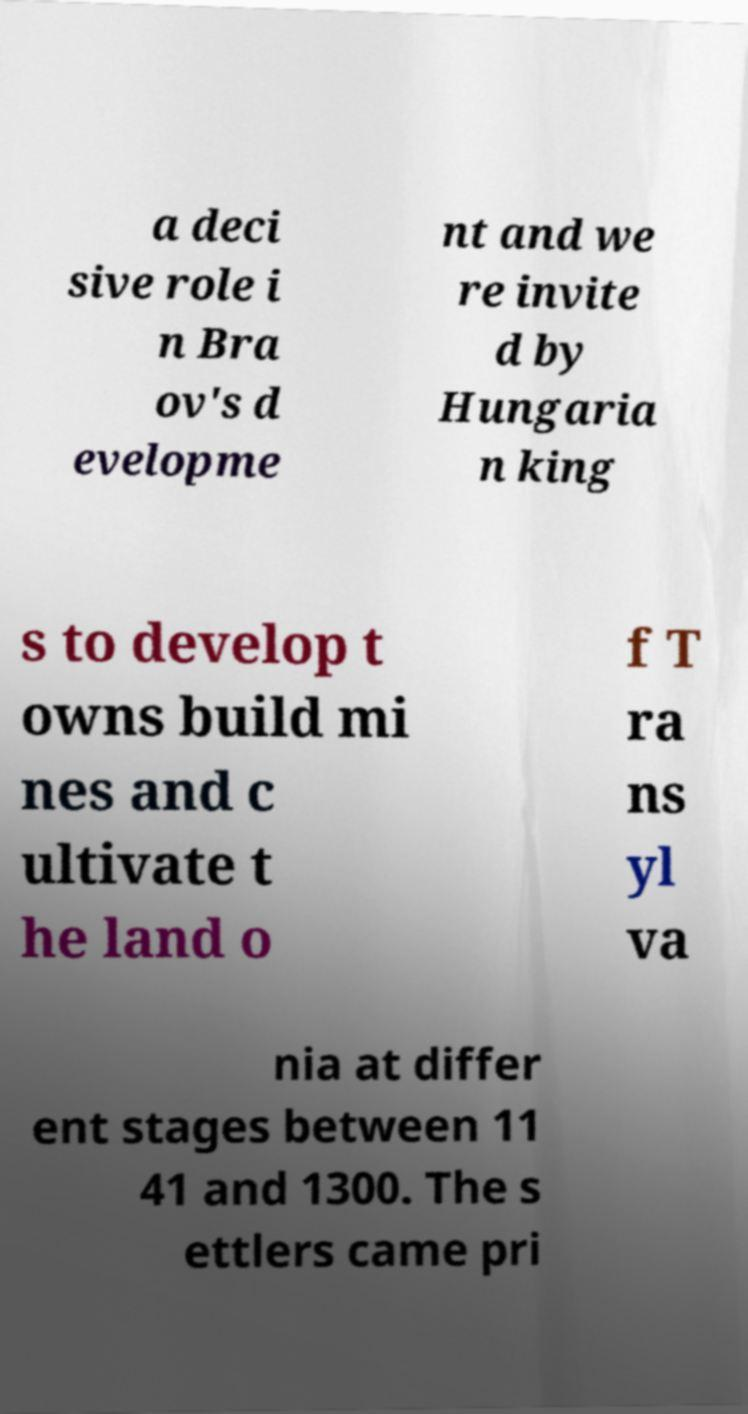Could you extract and type out the text from this image? a deci sive role i n Bra ov's d evelopme nt and we re invite d by Hungaria n king s to develop t owns build mi nes and c ultivate t he land o f T ra ns yl va nia at differ ent stages between 11 41 and 1300. The s ettlers came pri 